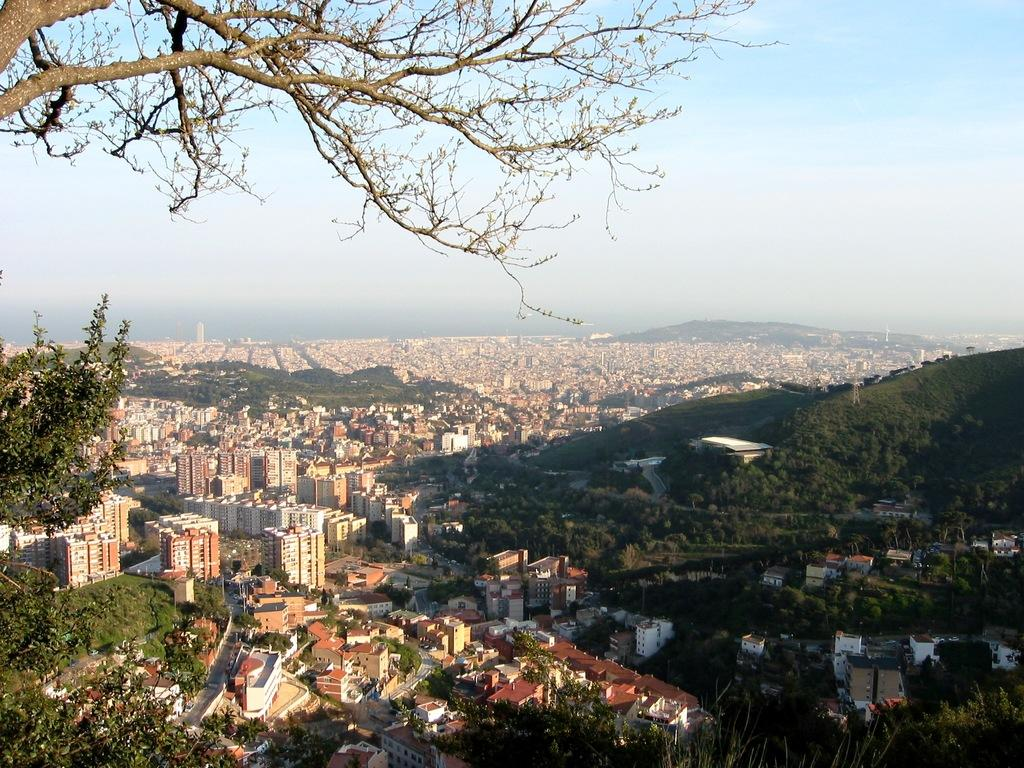What type of natural elements can be seen in the image? There are trees in the image. What type of man-made structures are present in the image? There are buildings in the image. What type of geographical feature can be seen in the image? There are mountains in the image. What is visible at the top of the image? The sky is visible at the top of the image. How far is the driving distance to the mountains in the image? There is no information about driving distance in the image, as it only shows the mountains in the background. What type of vehicle is being used to crush the trees in the image? There are no vehicles or crushing activities present in the image; it only shows trees, buildings, mountains, and the sky. 